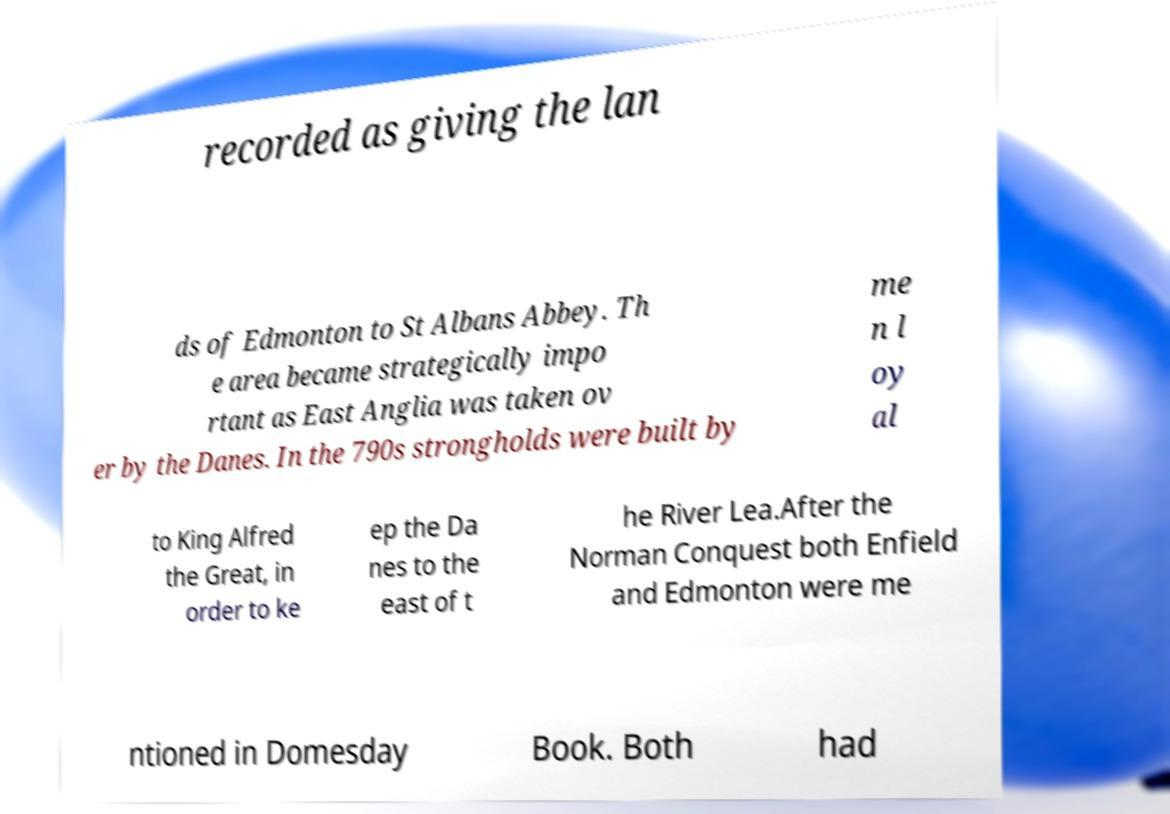Could you extract and type out the text from this image? recorded as giving the lan ds of Edmonton to St Albans Abbey. Th e area became strategically impo rtant as East Anglia was taken ov er by the Danes. In the 790s strongholds were built by me n l oy al to King Alfred the Great, in order to ke ep the Da nes to the east of t he River Lea.After the Norman Conquest both Enfield and Edmonton were me ntioned in Domesday Book. Both had 